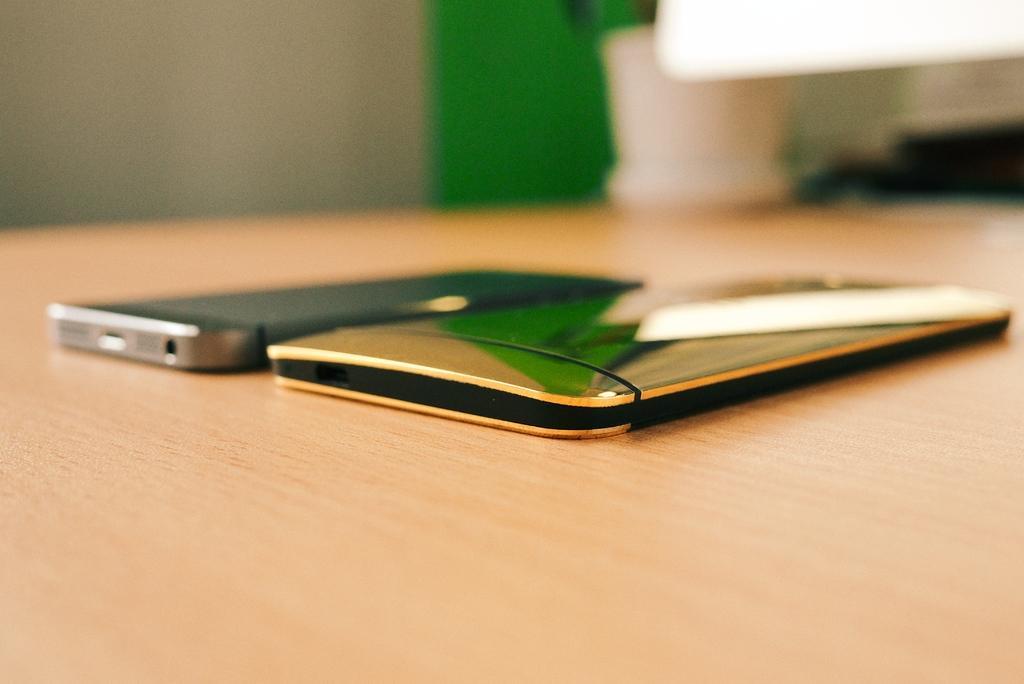In one or two sentences, can you explain what this image depicts? In this image I see 2 mobile phones on the light brown color surface and I see the white color thing over here and I can also see the green color thing over here and it is blurred in the background. 